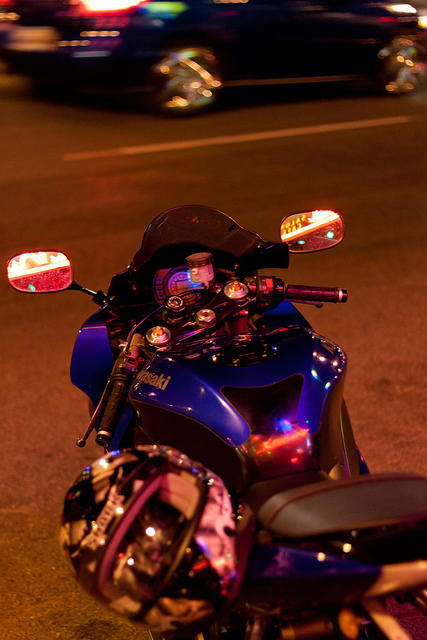Please transcribe the text in this image. nasaki 